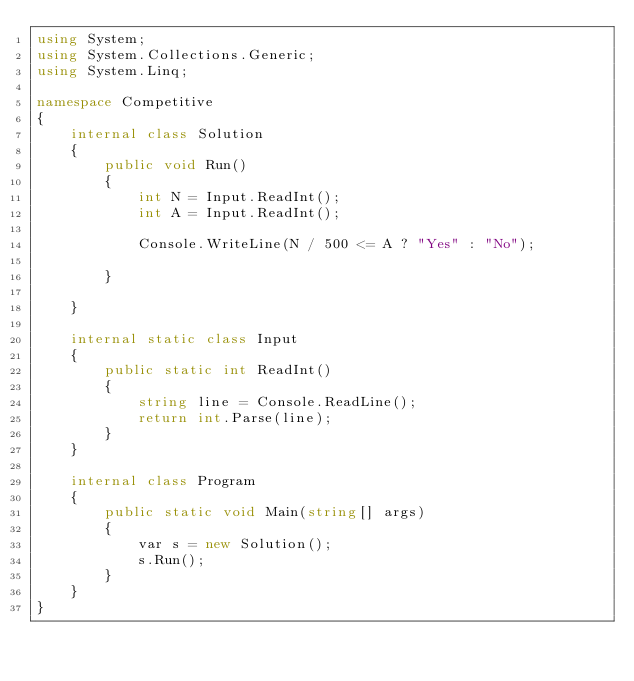Convert code to text. <code><loc_0><loc_0><loc_500><loc_500><_C#_>using System;
using System.Collections.Generic;
using System.Linq;

namespace Competitive
{
    internal class Solution
    {
        public void Run()
        {
            int N = Input.ReadInt();
            int A = Input.ReadInt();

            Console.WriteLine(N / 500 <= A ? "Yes" : "No");

        }

    }

    internal static class Input
    {
        public static int ReadInt()
        {
            string line = Console.ReadLine();
            return int.Parse(line);
        }
    }

    internal class Program
    {
        public static void Main(string[] args)
        {
            var s = new Solution();
            s.Run();
        }
    }
}</code> 